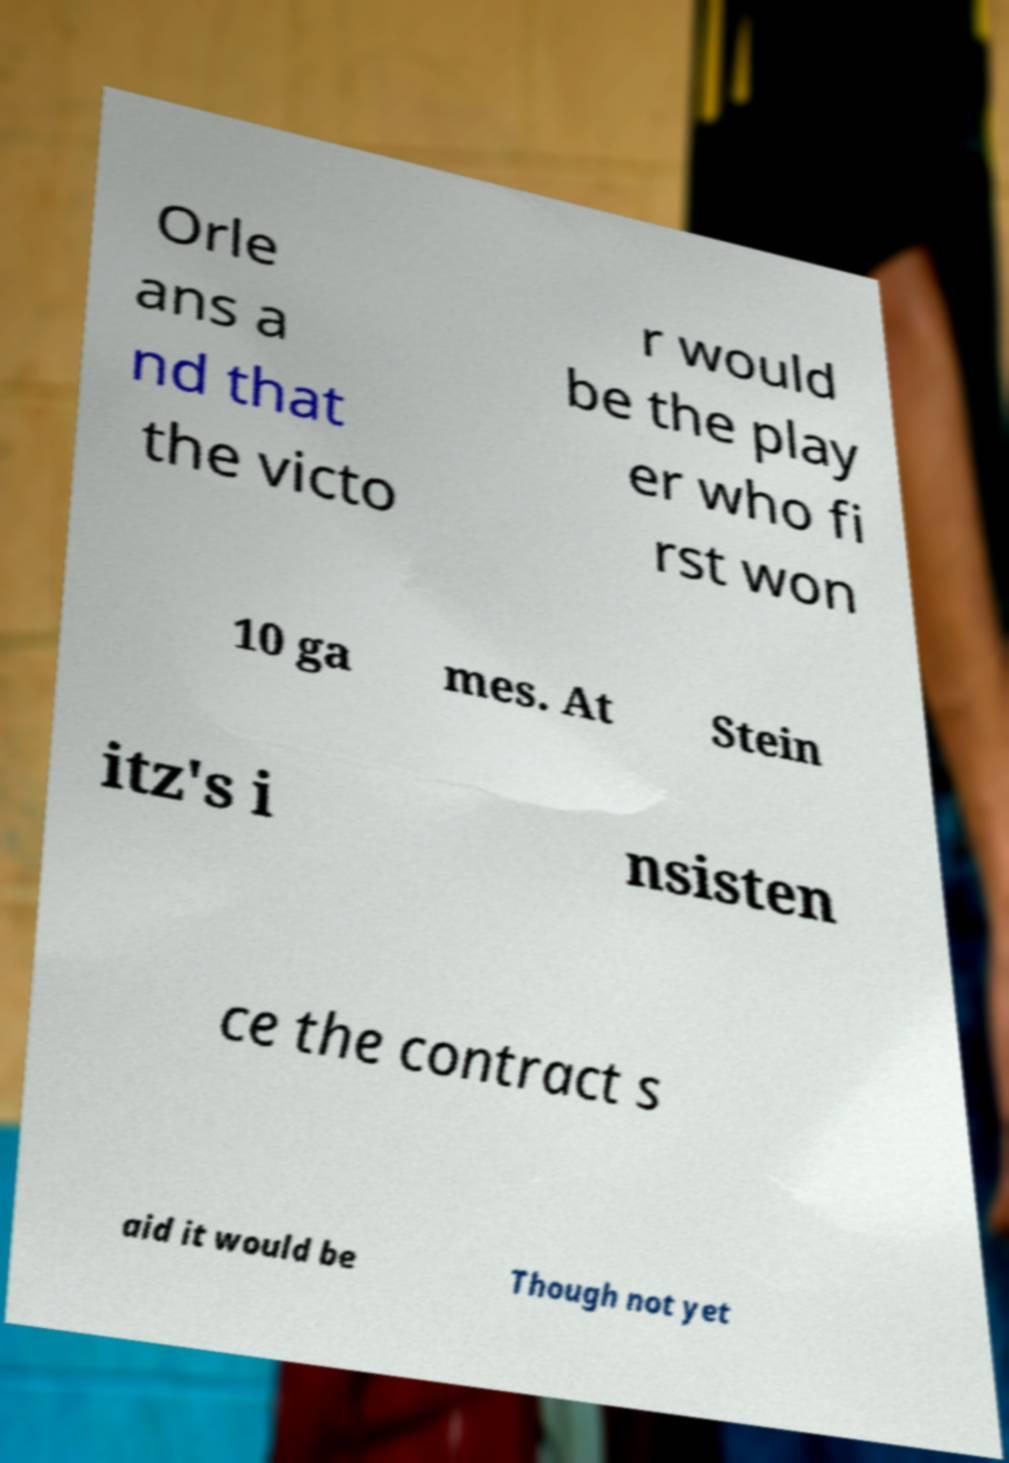I need the written content from this picture converted into text. Can you do that? Orle ans a nd that the victo r would be the play er who fi rst won 10 ga mes. At Stein itz's i nsisten ce the contract s aid it would be Though not yet 